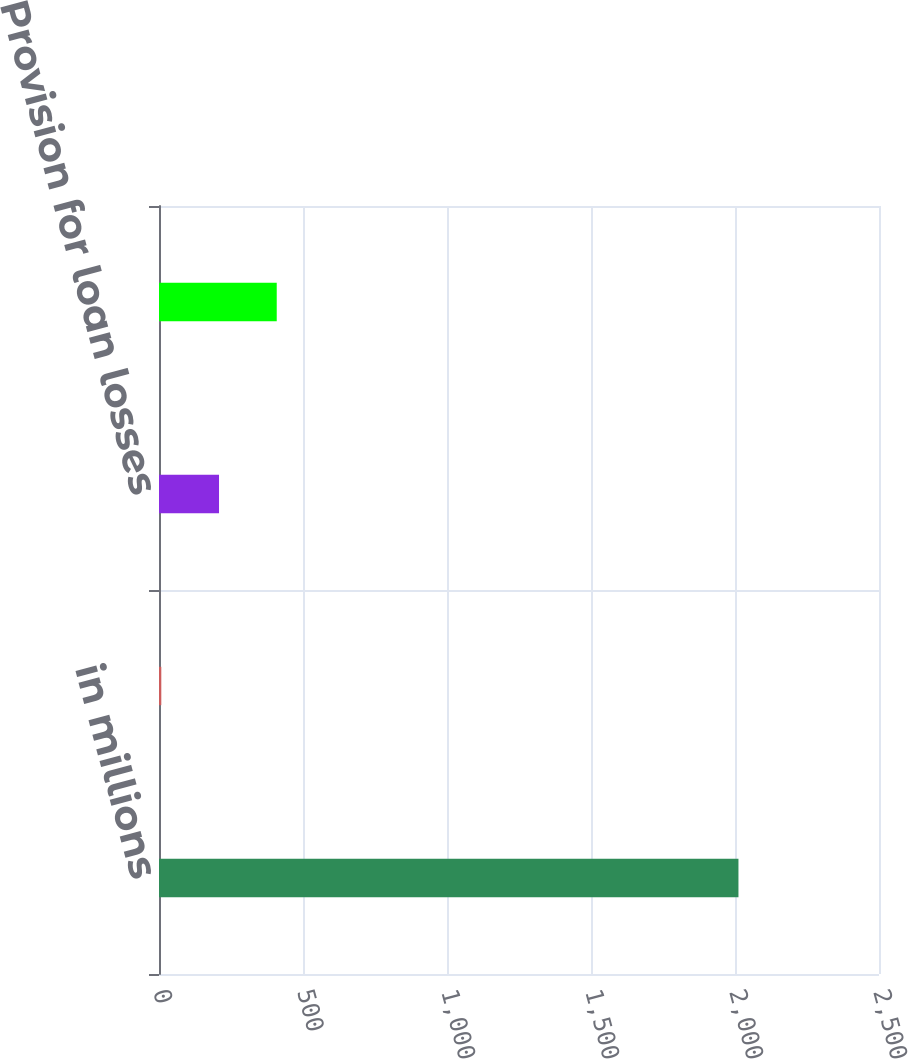<chart> <loc_0><loc_0><loc_500><loc_500><bar_chart><fcel>in millions<fcel>Balance beginning of period<fcel>Provision for loan losses<fcel>Balance end of period<nl><fcel>2012<fcel>8<fcel>208.4<fcel>408.8<nl></chart> 